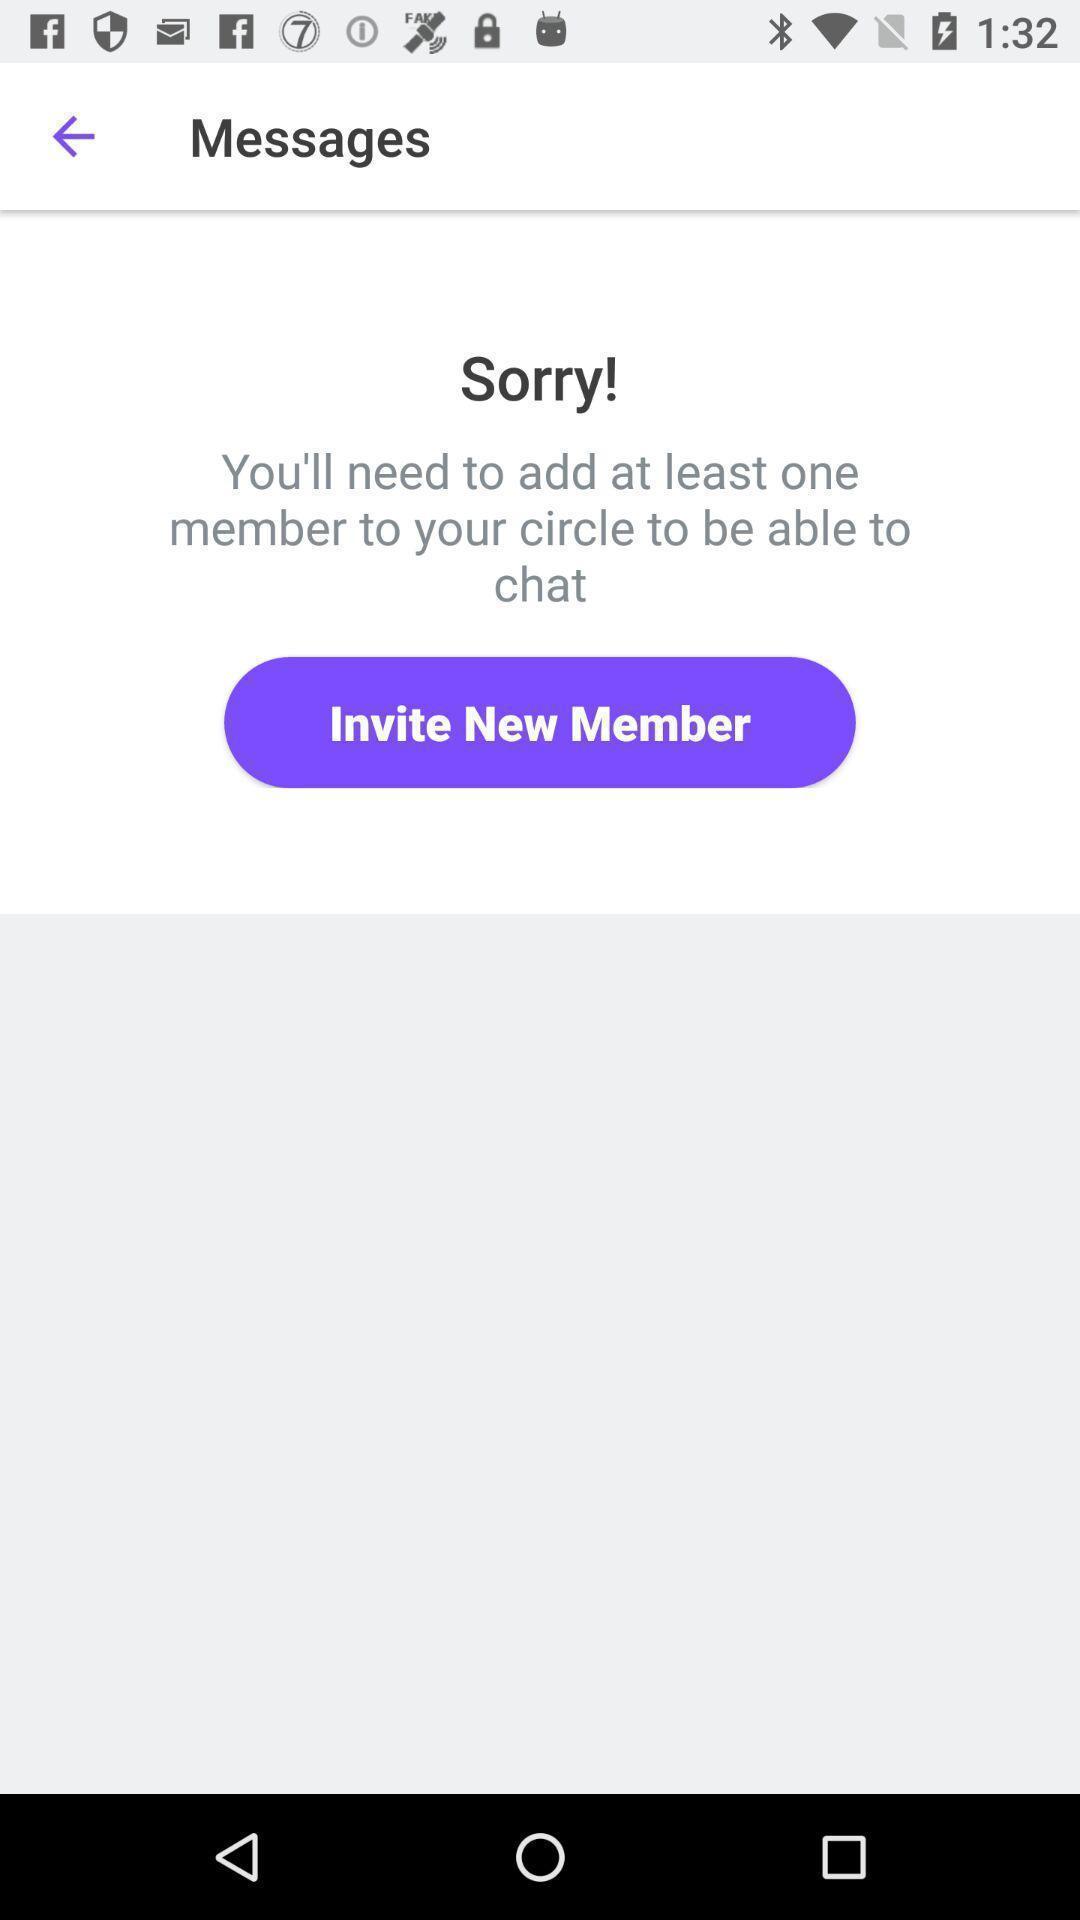Provide a detailed account of this screenshot. Screen displaying invite new member option. 